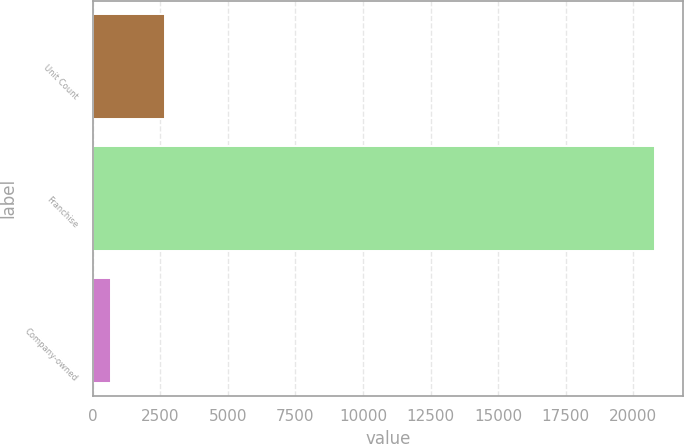<chart> <loc_0><loc_0><loc_500><loc_500><bar_chart><fcel>Unit Count<fcel>Franchise<fcel>Company-owned<nl><fcel>2683.1<fcel>20819<fcel>668<nl></chart> 